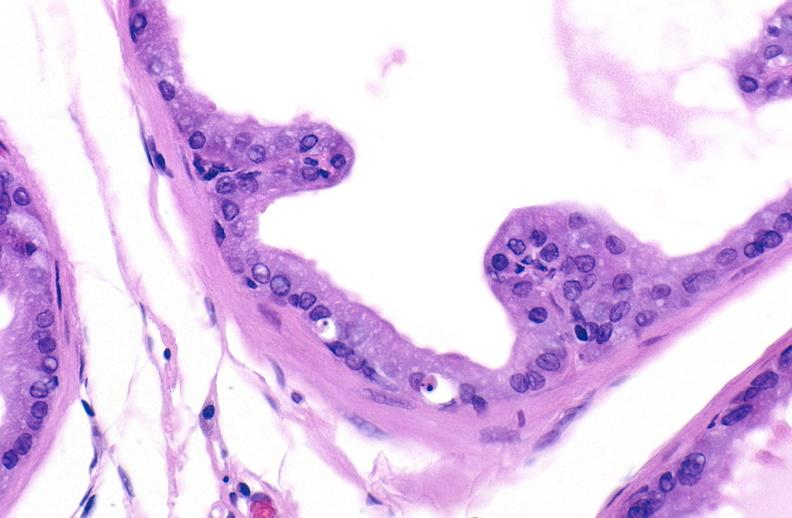what does this image show?
Answer the question using a single word or phrase. Apoptosis in prostate after orchiectomy 